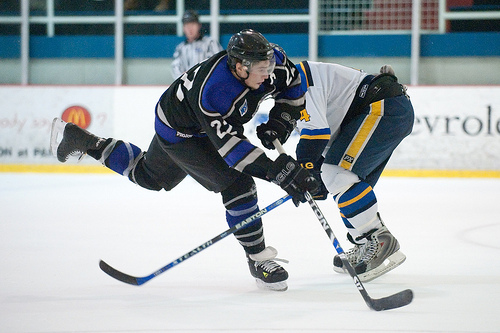<image>
Can you confirm if the man is on the player? Yes. Looking at the image, I can see the man is positioned on top of the player, with the player providing support. Is there a stick under the skate? No. The stick is not positioned under the skate. The vertical relationship between these objects is different. 